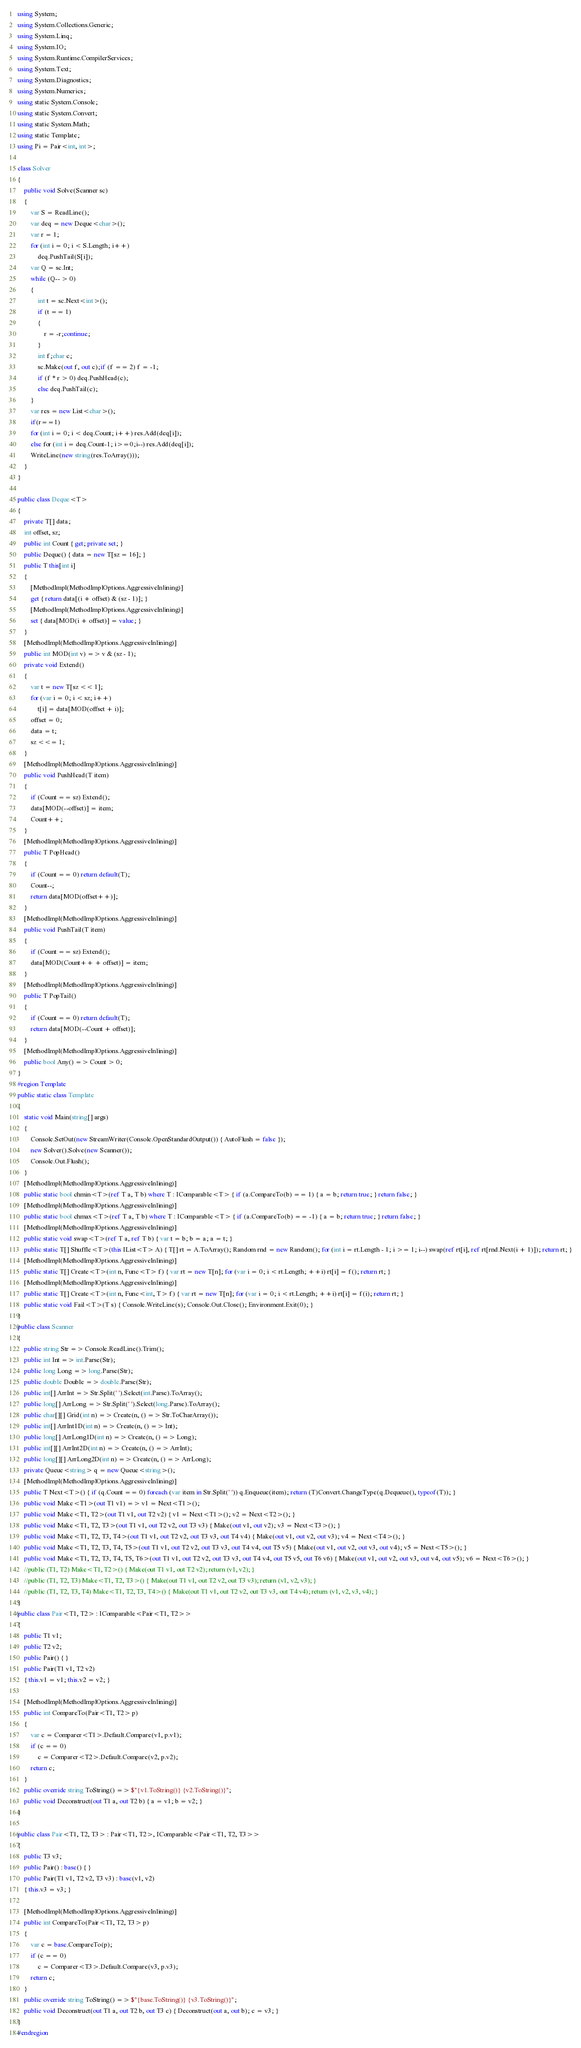<code> <loc_0><loc_0><loc_500><loc_500><_C#_>using System;
using System.Collections.Generic;
using System.Linq;
using System.IO;
using System.Runtime.CompilerServices;
using System.Text;
using System.Diagnostics;
using System.Numerics;
using static System.Console;
using static System.Convert;
using static System.Math;
using static Template;
using Pi = Pair<int, int>;

class Solver
{
    public void Solve(Scanner sc)
    {
        var S = ReadLine();
        var deq = new Deque<char>();
        var r = 1;
        for (int i = 0; i < S.Length; i++)
            deq.PushTail(S[i]);
        var Q = sc.Int;
        while (Q-- > 0)
        {
            int t = sc.Next<int>();
            if (t == 1)
            {
                r = -r;continue;
            }
            int f;char c;
            sc.Make(out f, out c);if (f == 2) f = -1;
            if (f * r > 0) deq.PushHead(c);
            else deq.PushTail(c);
        }
        var res = new List<char>();
        if(r==1)
        for (int i = 0; i < deq.Count; i++) res.Add(deq[i]);
        else for (int i = deq.Count-1; i>=0;i--) res.Add(deq[i]);
        WriteLine(new string(res.ToArray()));
    }
}

public class Deque<T>
{
    private T[] data;
    int offset, sz;
    public int Count { get; private set; }
    public Deque() { data = new T[sz = 16]; }
    public T this[int i]
    {
        [MethodImpl(MethodImplOptions.AggressiveInlining)]
        get { return data[(i + offset) & (sz - 1)]; }
        [MethodImpl(MethodImplOptions.AggressiveInlining)]
        set { data[MOD(i + offset)] = value; }
    }
    [MethodImpl(MethodImplOptions.AggressiveInlining)]
    public int MOD(int v) => v & (sz - 1);
    private void Extend()
    {
        var t = new T[sz << 1];
        for (var i = 0; i < sz; i++)
            t[i] = data[MOD(offset + i)];
        offset = 0;
        data = t;
        sz <<= 1;
    }
    [MethodImpl(MethodImplOptions.AggressiveInlining)]
    public void PushHead(T item)
    {
        if (Count == sz) Extend();
        data[MOD(--offset)] = item;
        Count++;
    }
    [MethodImpl(MethodImplOptions.AggressiveInlining)]
    public T PopHead()
    {
        if (Count == 0) return default(T);
        Count--;
        return data[MOD(offset++)];
    }
    [MethodImpl(MethodImplOptions.AggressiveInlining)]
    public void PushTail(T item)
    {
        if (Count == sz) Extend();
        data[MOD(Count++ + offset)] = item;
    }
    [MethodImpl(MethodImplOptions.AggressiveInlining)]
    public T PopTail()
    {
        if (Count == 0) return default(T);
        return data[MOD(--Count + offset)];
    }
    [MethodImpl(MethodImplOptions.AggressiveInlining)]
    public bool Any() => Count > 0;
}
#region Template
public static class Template
{
    static void Main(string[] args)
    {
        Console.SetOut(new StreamWriter(Console.OpenStandardOutput()) { AutoFlush = false });
        new Solver().Solve(new Scanner());
        Console.Out.Flush();
    }
    [MethodImpl(MethodImplOptions.AggressiveInlining)]
    public static bool chmin<T>(ref T a, T b) where T : IComparable<T> { if (a.CompareTo(b) == 1) { a = b; return true; } return false; }
    [MethodImpl(MethodImplOptions.AggressiveInlining)]
    public static bool chmax<T>(ref T a, T b) where T : IComparable<T> { if (a.CompareTo(b) == -1) { a = b; return true; } return false; }
    [MethodImpl(MethodImplOptions.AggressiveInlining)]
    public static void swap<T>(ref T a, ref T b) { var t = b; b = a; a = t; }
    public static T[] Shuffle<T>(this IList<T> A) { T[] rt = A.ToArray(); Random rnd = new Random(); for (int i = rt.Length - 1; i >= 1; i--) swap(ref rt[i], ref rt[rnd.Next(i + 1)]); return rt; }
    [MethodImpl(MethodImplOptions.AggressiveInlining)]
    public static T[] Create<T>(int n, Func<T> f) { var rt = new T[n]; for (var i = 0; i < rt.Length; ++i) rt[i] = f(); return rt; }
    [MethodImpl(MethodImplOptions.AggressiveInlining)]
    public static T[] Create<T>(int n, Func<int, T> f) { var rt = new T[n]; for (var i = 0; i < rt.Length; ++i) rt[i] = f(i); return rt; }
    public static void Fail<T>(T s) { Console.WriteLine(s); Console.Out.Close(); Environment.Exit(0); }
}
public class Scanner
{
    public string Str => Console.ReadLine().Trim();
    public int Int => int.Parse(Str);
    public long Long => long.Parse(Str);
    public double Double => double.Parse(Str);
    public int[] ArrInt => Str.Split(' ').Select(int.Parse).ToArray();
    public long[] ArrLong => Str.Split(' ').Select(long.Parse).ToArray();
    public char[][] Grid(int n) => Create(n, () => Str.ToCharArray());
    public int[] ArrInt1D(int n) => Create(n, () => Int);
    public long[] ArrLong1D(int n) => Create(n, () => Long);
    public int[][] ArrInt2D(int n) => Create(n, () => ArrInt);
    public long[][] ArrLong2D(int n) => Create(n, () => ArrLong);
    private Queue<string> q = new Queue<string>();
    [MethodImpl(MethodImplOptions.AggressiveInlining)]
    public T Next<T>() { if (q.Count == 0) foreach (var item in Str.Split(' ')) q.Enqueue(item); return (T)Convert.ChangeType(q.Dequeue(), typeof(T)); }
    public void Make<T1>(out T1 v1) => v1 = Next<T1>();
    public void Make<T1, T2>(out T1 v1, out T2 v2) { v1 = Next<T1>(); v2 = Next<T2>(); }
    public void Make<T1, T2, T3>(out T1 v1, out T2 v2, out T3 v3) { Make(out v1, out v2); v3 = Next<T3>(); }
    public void Make<T1, T2, T3, T4>(out T1 v1, out T2 v2, out T3 v3, out T4 v4) { Make(out v1, out v2, out v3); v4 = Next<T4>(); }
    public void Make<T1, T2, T3, T4, T5>(out T1 v1, out T2 v2, out T3 v3, out T4 v4, out T5 v5) { Make(out v1, out v2, out v3, out v4); v5 = Next<T5>(); }
    public void Make<T1, T2, T3, T4, T5, T6>(out T1 v1, out T2 v2, out T3 v3, out T4 v4, out T5 v5, out T6 v6) { Make(out v1, out v2, out v3, out v4, out v5); v6 = Next<T6>(); }
    //public (T1, T2) Make<T1, T2>() { Make(out T1 v1, out T2 v2); return (v1, v2); }
    //public (T1, T2, T3) Make<T1, T2, T3>() { Make(out T1 v1, out T2 v2, out T3 v3); return (v1, v2, v3); }
    //public (T1, T2, T3, T4) Make<T1, T2, T3, T4>() { Make(out T1 v1, out T2 v2, out T3 v3, out T4 v4); return (v1, v2, v3, v4); }
}
public class Pair<T1, T2> : IComparable<Pair<T1, T2>>
{
    public T1 v1;
    public T2 v2;
    public Pair() { }
    public Pair(T1 v1, T2 v2)
    { this.v1 = v1; this.v2 = v2; }

    [MethodImpl(MethodImplOptions.AggressiveInlining)]
    public int CompareTo(Pair<T1, T2> p)
    {
        var c = Comparer<T1>.Default.Compare(v1, p.v1);
        if (c == 0)
            c = Comparer<T2>.Default.Compare(v2, p.v2);
        return c;
    }
    public override string ToString() => $"{v1.ToString()} {v2.ToString()}";
    public void Deconstruct(out T1 a, out T2 b) { a = v1; b = v2; }
}

public class Pair<T1, T2, T3> : Pair<T1, T2>, IComparable<Pair<T1, T2, T3>>
{
    public T3 v3;
    public Pair() : base() { }
    public Pair(T1 v1, T2 v2, T3 v3) : base(v1, v2)
    { this.v3 = v3; }

    [MethodImpl(MethodImplOptions.AggressiveInlining)]
    public int CompareTo(Pair<T1, T2, T3> p)
    {
        var c = base.CompareTo(p);
        if (c == 0)
            c = Comparer<T3>.Default.Compare(v3, p.v3);
        return c;
    }
    public override string ToString() => $"{base.ToString()} {v3.ToString()}";
    public void Deconstruct(out T1 a, out T2 b, out T3 c) { Deconstruct(out a, out b); c = v3; }
}
#endregion</code> 